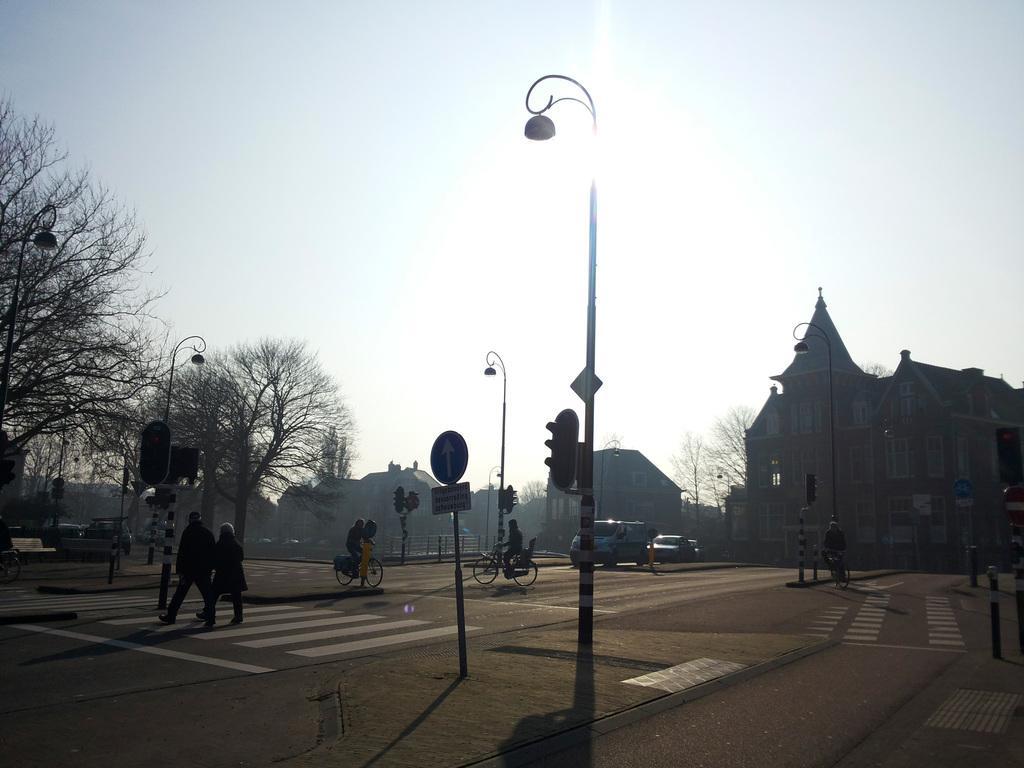Can you describe this image briefly? This picture is clicked outside the city. Here, we see three men riding bicycles on the road. We even see two people crossing the road. There are vehicles moving on the road. In the middle of the picture, we see traffic lights and we even see street lights. There are many trees and buildings in the background. At the top of the picture, we see the sky and the sun. 